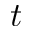Convert formula to latex. <formula><loc_0><loc_0><loc_500><loc_500>t</formula> 